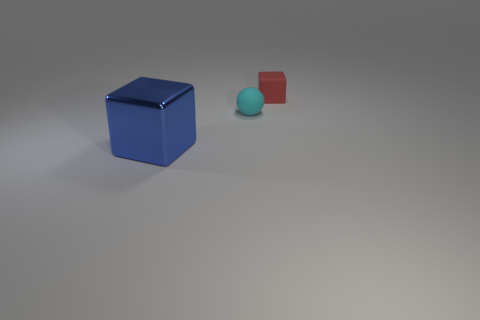There is another thing that is the same shape as the large shiny object; what is its size?
Keep it short and to the point. Small. What number of other blocks are the same color as the large cube?
Make the answer very short. 0. How many objects are either cubes that are behind the big block or purple cylinders?
Your response must be concise. 1. The small cube that is made of the same material as the tiny sphere is what color?
Provide a succinct answer. Red. Is there another object that has the same size as the red rubber thing?
Your answer should be very brief. Yes. What number of objects are objects that are behind the big blue metallic block or cubes in front of the red rubber block?
Provide a short and direct response. 3. There is a cyan rubber thing that is the same size as the red rubber thing; what is its shape?
Ensure brevity in your answer.  Sphere. Are there any other small objects that have the same shape as the tiny cyan thing?
Provide a succinct answer. No. Are there fewer large blue shiny things than small gray cubes?
Make the answer very short. No. Does the block that is left of the small ball have the same size as the matte object in front of the small matte block?
Your response must be concise. No. 